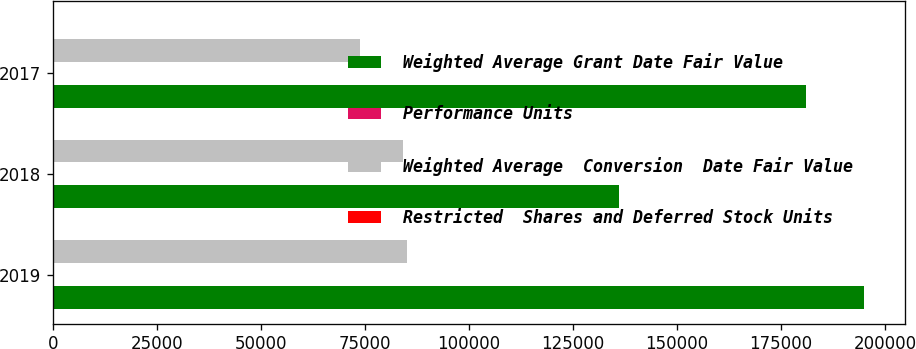<chart> <loc_0><loc_0><loc_500><loc_500><stacked_bar_chart><ecel><fcel>2019<fcel>2018<fcel>2017<nl><fcel>Weighted Average Grant Date Fair Value<fcel>194932<fcel>136127<fcel>180997<nl><fcel>Performance Units<fcel>104.33<fcel>126.8<fcel>133.92<nl><fcel>Weighted Average  Conversion  Date Fair Value<fcel>85154<fcel>84051<fcel>73701<nl><fcel>Restricted  Shares and Deferred Stock Units<fcel>123.68<fcel>103.86<fcel>126.8<nl></chart> 